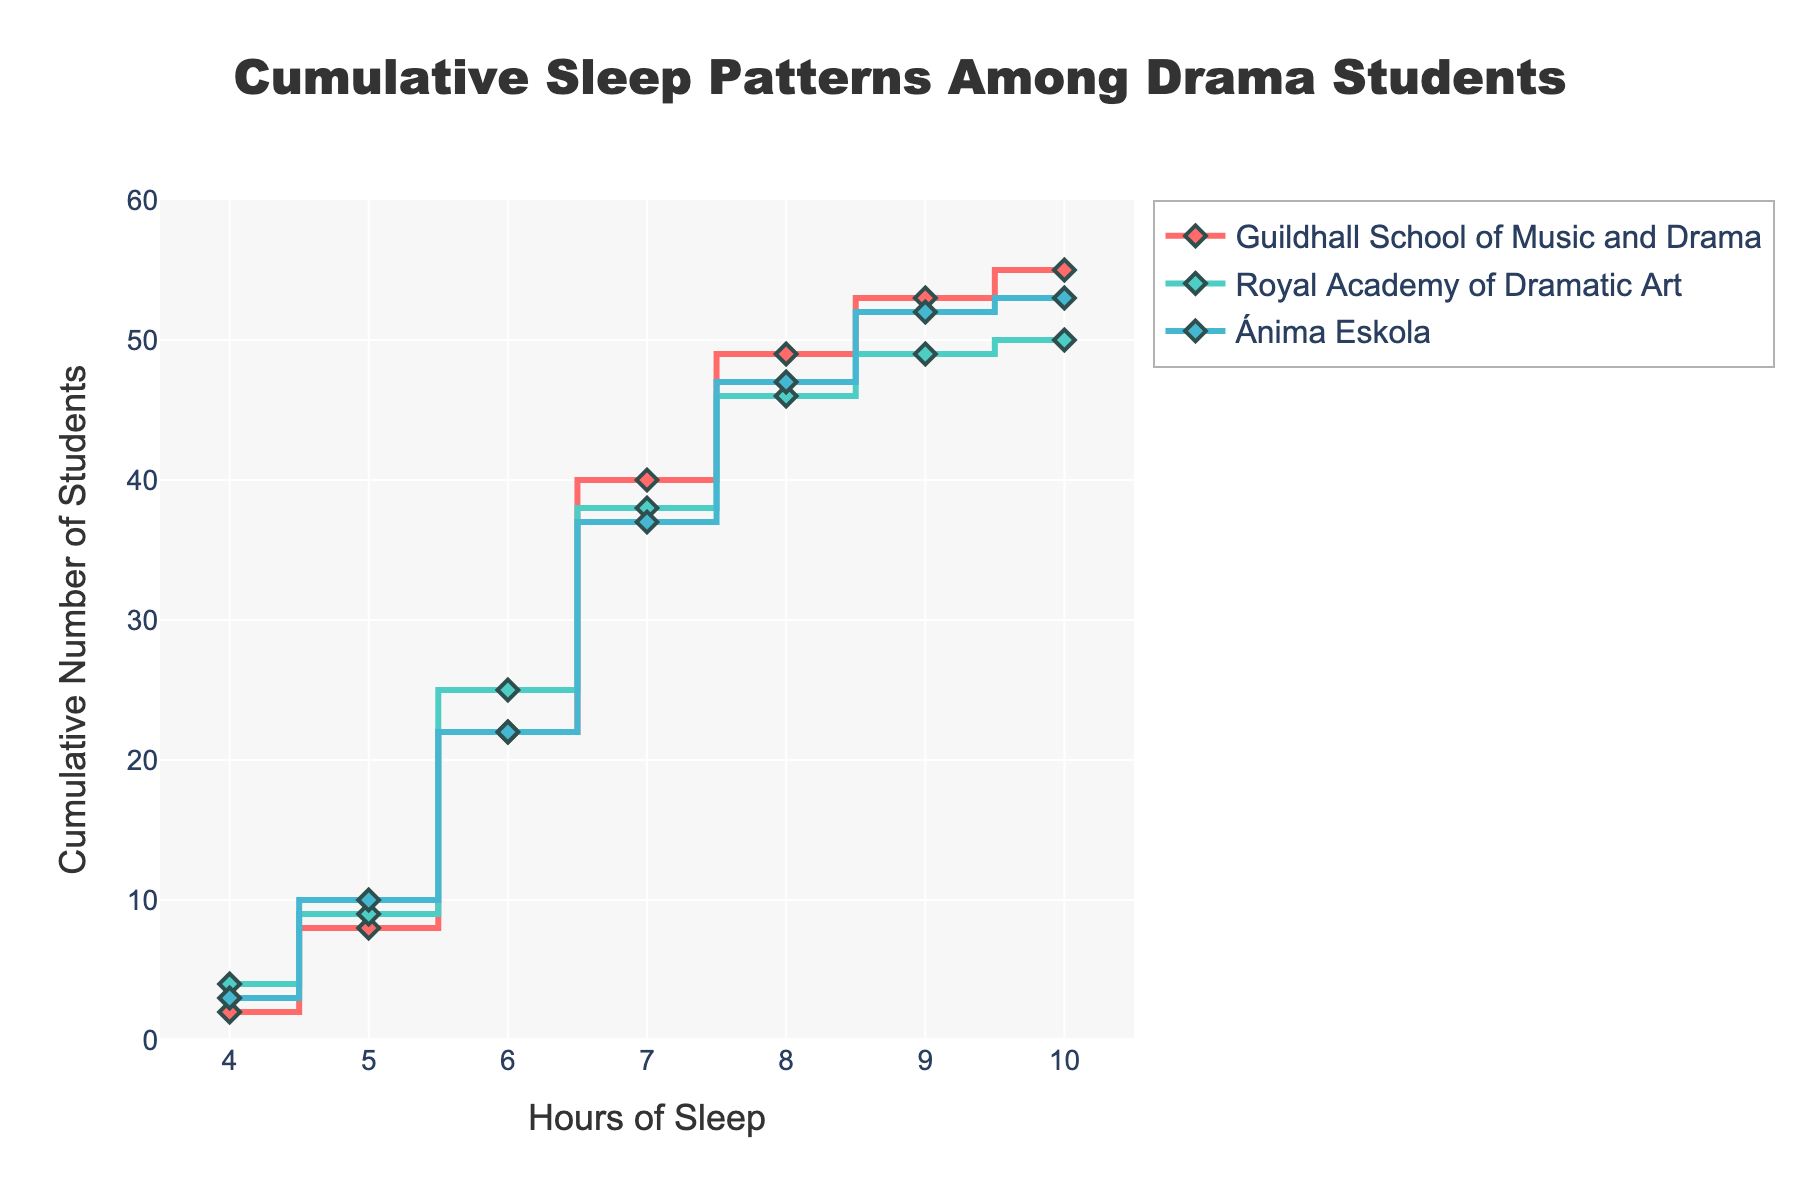What's the title of the plot? The title is written at the top of the plot and it's "Cumulative Sleep Patterns Among Drama Students".
Answer: Cumulative Sleep Patterns Among Drama Students What are the labels for the x-axis and y-axis? The x-axis label is 'Hours of Sleep' and the y-axis label is 'Cumulative Number of Students' as mentioned in the plot.
Answer: Hours of Sleep and Cumulative Number of Students Which school has the highest cumulative number of students at 6 hours of sleep? To answer this, look at the cumulative values at 6 hours of sleep for each school. For Ánima Eskola, it's 22; for Guildhall, it's 22; and for Royal Academy, it's 25. Therefore, Royal Academy of Dramatic Art has the highest number.
Answer: Royal Academy of Dramatic Art Which color represents the 'Guildhall School of Music and Drama'? The colors are indicated in the legend. The 'Guildhall School of Music and Drama' is represented by a turquoise-like color.
Answer: Turquoise-like color How many cumulative students in Ánima Eskola sleep 7 hours or more? At 7 hours, there are 37 students; at 8 hours, it's 47; at 9 hours, it's 52; and at 10 hours, it's 53. Thus, for 7 hours or more, the cumulative count is 53.
Answer: 53 students What is the trend in the number of students as hours of sleep increase for all schools? As hours of sleep increase, the cumulative number of students increases gradually for all the schools, with small differences in the slope and final values.
Answer: Increasing trend Compare the cumulative student count for Guildhall at 5 hours and 9 hours? At 5 hours, Guildhall has 8 students; at 9 hours, it has 53 students. The difference is 45 students.
Answer: 45 students What's the sum of cumulative students for Royal Academy at 5 and 10 hours? Royal Academy has 9 students at 5 hours and 50 students at 10 hours. The sum is 9 + 50 = 59 students.
Answer: 59 students How do the stair steps differ among the three schools? The stair steps show how the cumulative number of students increase by the hour. Ánima Eskola shows more gradual steps while Guildhall and Royal Academy show steeper climbs especially in the middle ranges.
Answer: Different stair-step patterns Do any of the schools have the same cumulative number of students at any hour? Yes, examples include both Ánima Eskola and Guildhall having 12 students at 5 hours, among others. You need to check specific hour values in the plot to find them.
Answer: Yes 